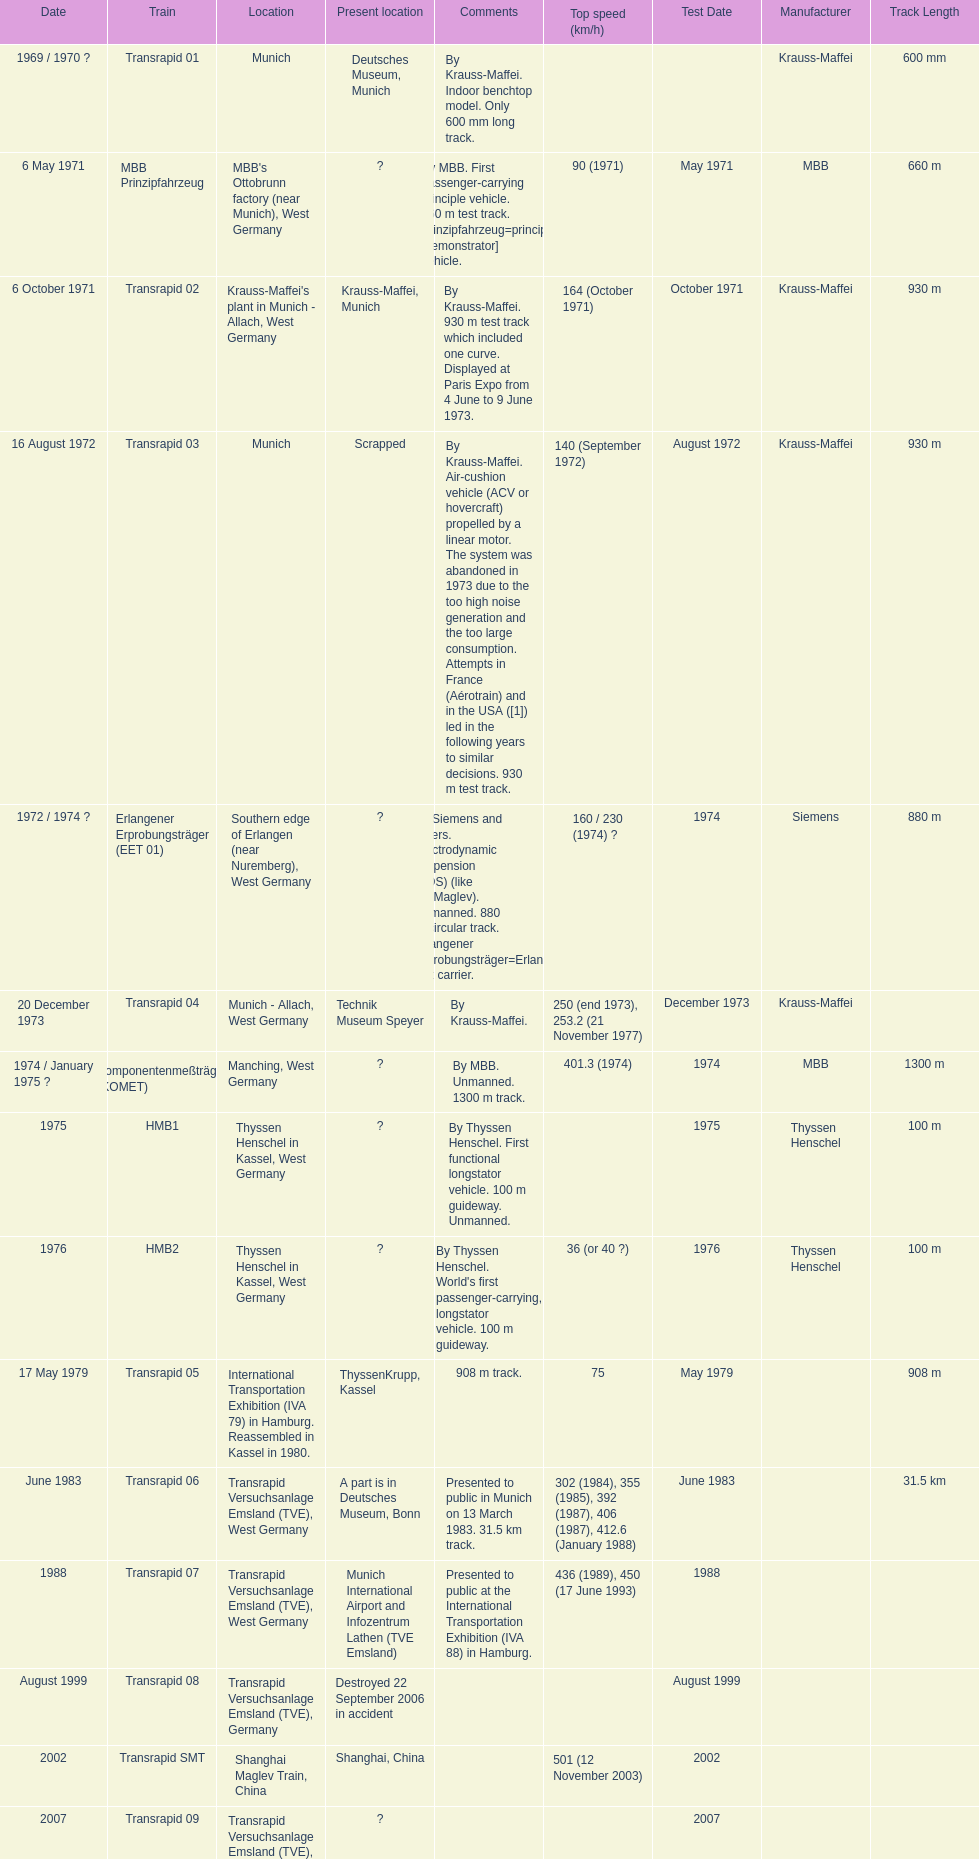Could you parse the entire table as a dict? {'header': ['Date', 'Train', 'Location', 'Present location', 'Comments', 'Top speed (km/h)', 'Test Date', 'Manufacturer', 'Track Length'], 'rows': [['1969 / 1970\xa0?', 'Transrapid 01', 'Munich', 'Deutsches Museum, Munich', 'By Krauss-Maffei. Indoor benchtop model. Only 600\xa0mm long track.', '', '', 'Krauss-Maffei', '600 mm'], ['6 May 1971', 'MBB Prinzipfahrzeug', "MBB's Ottobrunn factory (near Munich), West Germany", '?', 'By MBB. First passenger-carrying principle vehicle. 660 m test track. Prinzipfahrzeug=principle [demonstrator] vehicle.', '90 (1971)', 'May 1971', 'MBB', '660 m'], ['6 October 1971', 'Transrapid 02', "Krauss-Maffei's plant in Munich - Allach, West Germany", 'Krauss-Maffei, Munich', 'By Krauss-Maffei. 930 m test track which included one curve. Displayed at Paris Expo from 4 June to 9 June 1973.', '164 (October 1971)', 'October 1971', 'Krauss-Maffei', '930 m'], ['16 August 1972', 'Transrapid 03', 'Munich', 'Scrapped', 'By Krauss-Maffei. Air-cushion vehicle (ACV or hovercraft) propelled by a linear motor. The system was abandoned in 1973 due to the too high noise generation and the too large consumption. Attempts in France (Aérotrain) and in the USA ([1]) led in the following years to similar decisions. 930 m test track.', '140 (September 1972)', 'August 1972', 'Krauss-Maffei', '930 m'], ['1972 / 1974\xa0?', 'Erlangener Erprobungsträger (EET 01)', 'Southern edge of Erlangen (near Nuremberg), West Germany', '?', 'By Siemens and others. Electrodynamic suspension (EDS) (like JR-Maglev). Unmanned. 880 m circular track. Erlangener Erprobungsträger=Erlangen test carrier.', '160 / 230 (1974)\xa0?', '1974', 'Siemens', '880 m'], ['20 December 1973', 'Transrapid 04', 'Munich - Allach, West Germany', 'Technik Museum Speyer', 'By Krauss-Maffei.', '250 (end 1973), 253.2 (21 November 1977)', 'December 1973', 'Krauss-Maffei', ''], ['1974 / January 1975\xa0?', 'Komponentenmeßträger (KOMET)', 'Manching, West Germany', '?', 'By MBB. Unmanned. 1300 m track.', '401.3 (1974)', '1974', 'MBB', '1300 m'], ['1975', 'HMB1', 'Thyssen Henschel in Kassel, West Germany', '?', 'By Thyssen Henschel. First functional longstator vehicle. 100 m guideway. Unmanned.', '', '1975', 'Thyssen Henschel', '100 m'], ['1976', 'HMB2', 'Thyssen Henschel in Kassel, West Germany', '?', "By Thyssen Henschel. World's first passenger-carrying, longstator vehicle. 100 m guideway.", '36 (or 40\xa0?)', '1976', 'Thyssen Henschel', '100 m'], ['17 May 1979', 'Transrapid 05', 'International Transportation Exhibition (IVA 79) in Hamburg. Reassembled in Kassel in 1980.', 'ThyssenKrupp, Kassel', '908 m track.', '75', 'May 1979', '', '908 m'], ['June 1983', 'Transrapid 06', 'Transrapid Versuchsanlage Emsland (TVE), West Germany', 'A part is in Deutsches Museum, Bonn', 'Presented to public in Munich on 13 March 1983. 31.5\xa0km track.', '302 (1984), 355 (1985), 392 (1987), 406 (1987), 412.6 (January 1988)', 'June 1983', '', '31.5 km'], ['1988', 'Transrapid 07', 'Transrapid Versuchsanlage Emsland (TVE), West Germany', 'Munich International Airport and Infozentrum Lathen (TVE Emsland)', 'Presented to public at the International Transportation Exhibition (IVA 88) in Hamburg.', '436 (1989), 450 (17 June 1993)', '1988', '', ''], ['August 1999', 'Transrapid 08', 'Transrapid Versuchsanlage Emsland (TVE), Germany', 'Destroyed 22 September 2006 in accident', '', '', 'August 1999', '', ''], ['2002', 'Transrapid SMT', 'Shanghai Maglev Train, China', 'Shanghai, China', '', '501 (12 November 2003)', '2002', '', ''], ['2007', 'Transrapid 09', 'Transrapid Versuchsanlage Emsland (TVE), Germany', '?', '', '', '2007', '', '']]} What train was developed after the erlangener erprobungstrager? Transrapid 04. 